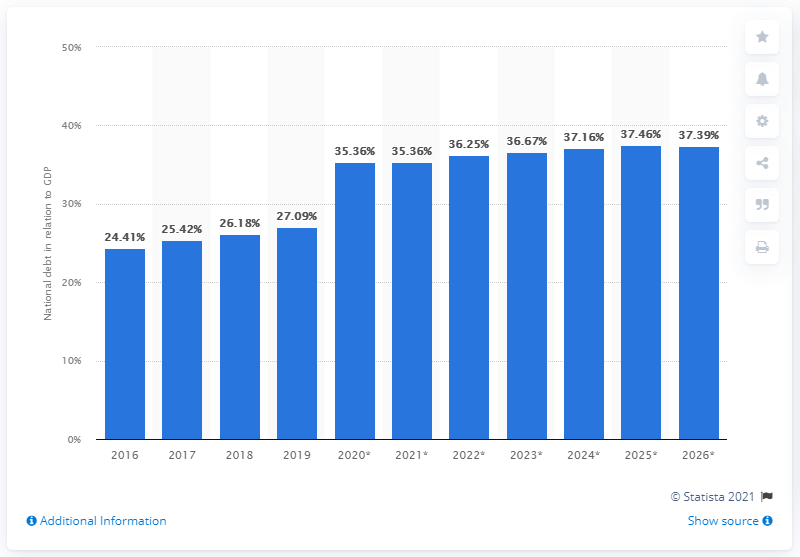Specify some key components in this picture. In 2019, the national debt of Peru constituted approximately 27.09% of the country's GDP. 